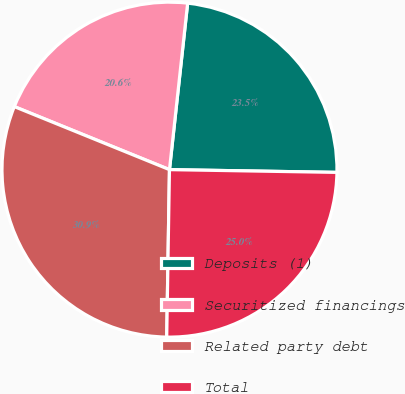<chart> <loc_0><loc_0><loc_500><loc_500><pie_chart><fcel>Deposits (1)<fcel>Securitized financings<fcel>Related party debt<fcel>Total<nl><fcel>23.53%<fcel>20.59%<fcel>30.88%<fcel>25.0%<nl></chart> 